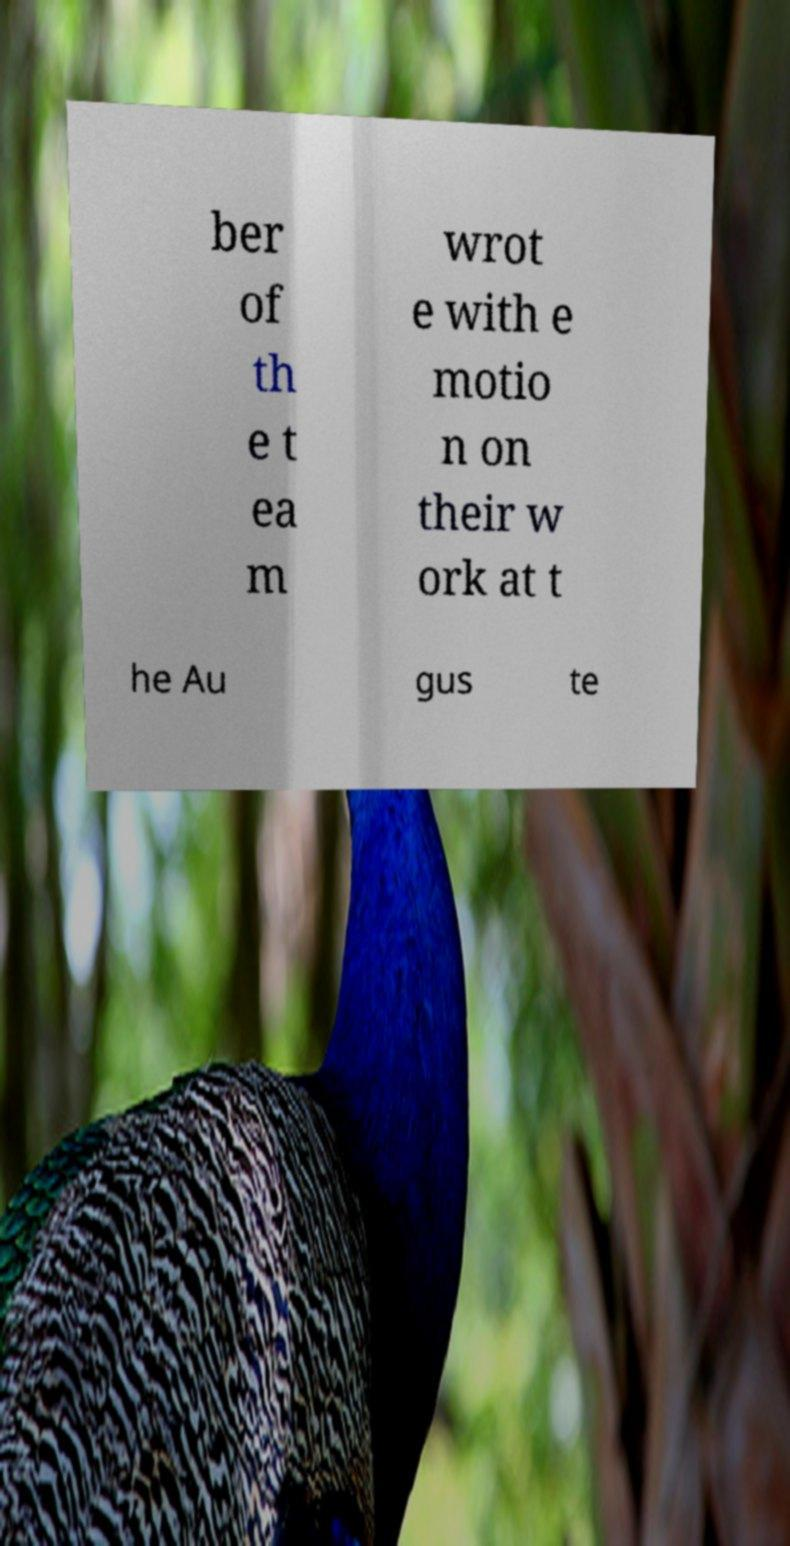There's text embedded in this image that I need extracted. Can you transcribe it verbatim? ber of th e t ea m wrot e with e motio n on their w ork at t he Au gus te 